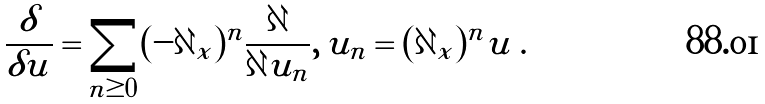<formula> <loc_0><loc_0><loc_500><loc_500>\frac { \delta } { \delta u } = \sum _ { n \geq 0 } ( - \partial _ { x } ) ^ { n } \frac { \partial } { \partial u _ { n } } , \, u _ { n } = ( \partial _ { x } ) ^ { n } u \, .</formula> 